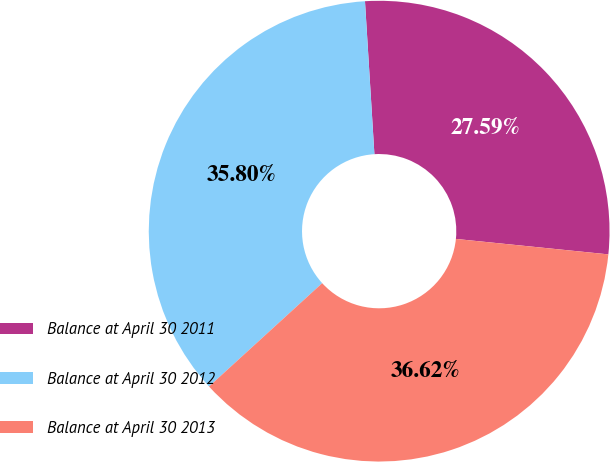<chart> <loc_0><loc_0><loc_500><loc_500><pie_chart><fcel>Balance at April 30 2011<fcel>Balance at April 30 2012<fcel>Balance at April 30 2013<nl><fcel>27.59%<fcel>35.8%<fcel>36.62%<nl></chart> 